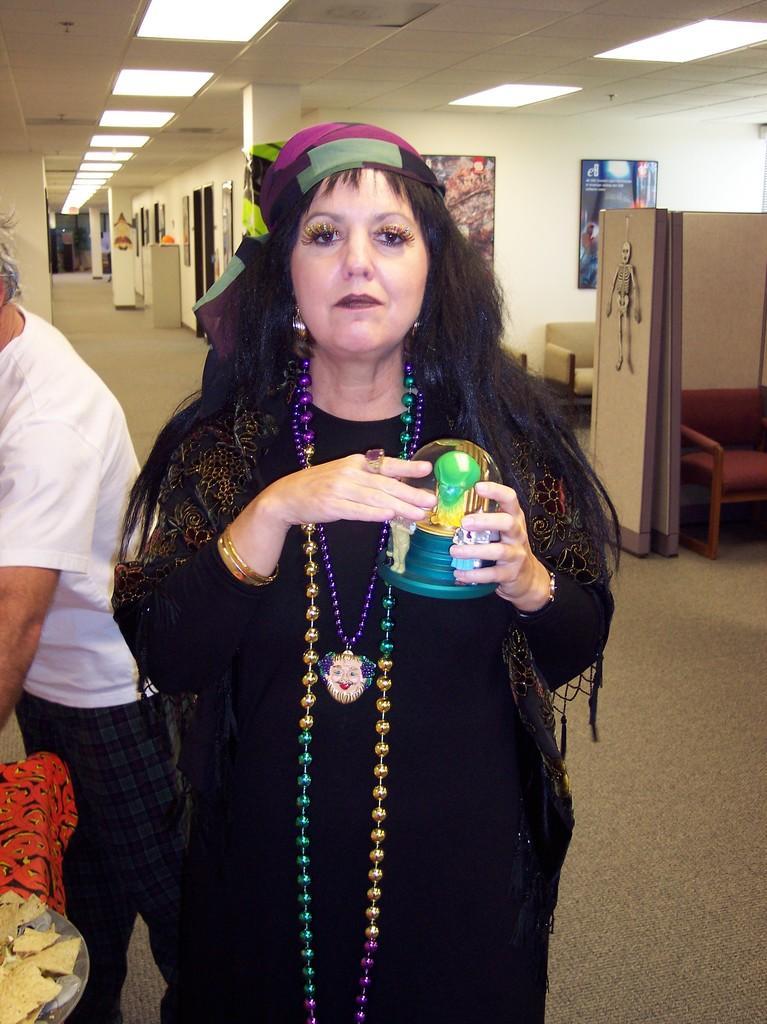How would you summarize this image in a sentence or two? This is a picture taken in a building. In the foreground there is a woman holding an object. On the left there is another person standing. At the top there are lights to the ceiling. In the background there are doors, windows and some objects. On the right there are posters, couch and wall. 